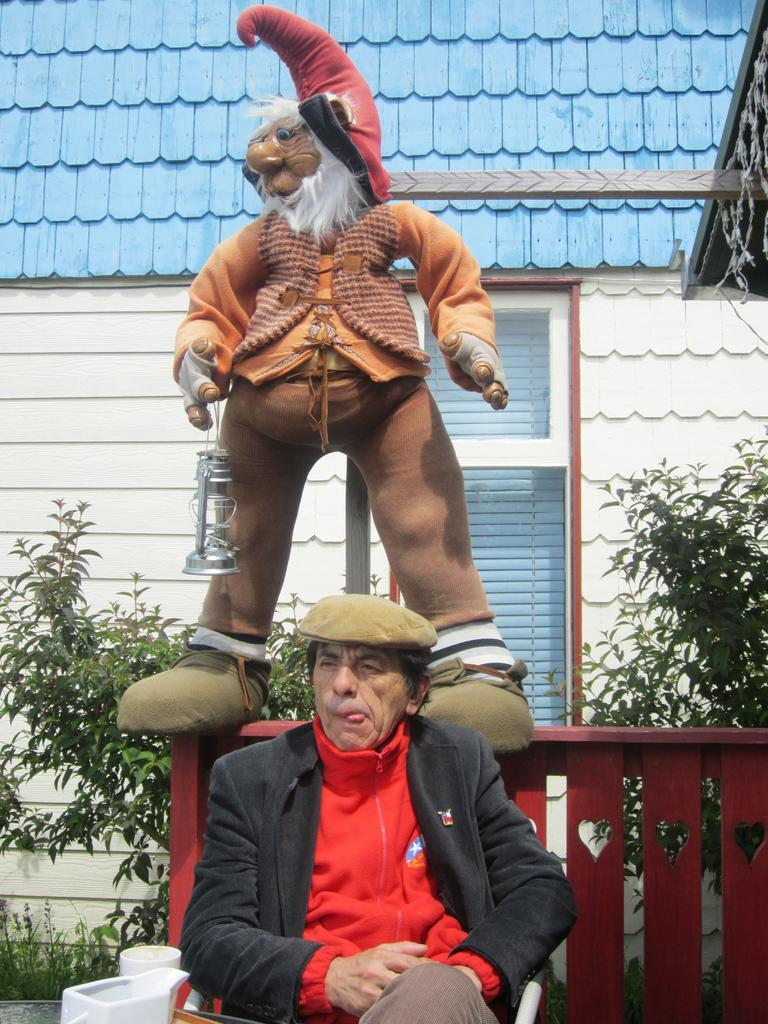What is the man in the image doing? The man is sitting on a chair in the image. What object can be seen on the fence? There is a toy on the fence. What type of natural environment is visible in the image? There are trees visible in the image. What type of structure can be seen in the background? There is a house in the background of the image. Where is the nearest zoo to the location depicted in the image? The image does not provide information about the location or the nearest zoo. 